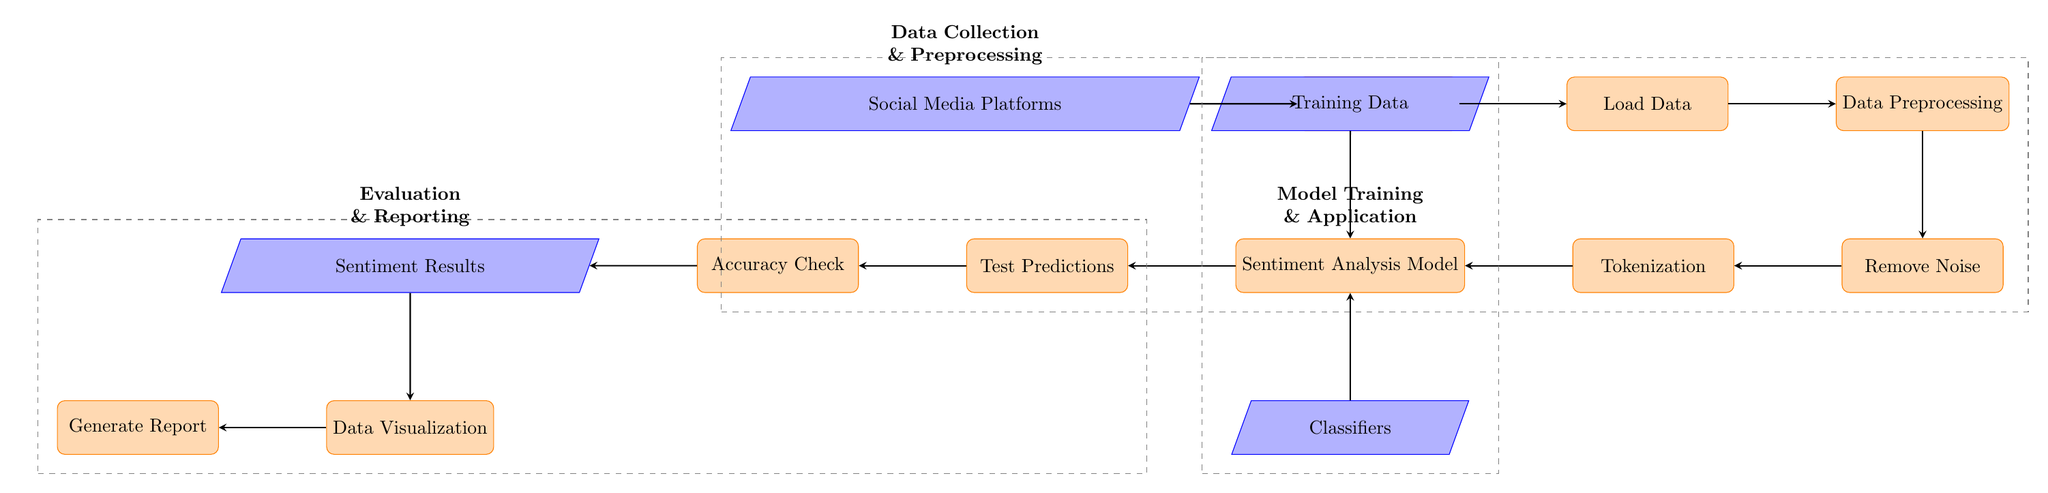What is the first step in the workflow? The first step in the workflow is represented by the node labeled "Social Media Platforms," which signifies where data is sourced from for further processing.
Answer: Social Media Platforms How many nodes are represented in the diagram? By counting each distinct labeled box in the diagram, we find there are a total of 12 nodes representing various parts of the workflow.
Answer: 12 What is the purpose of the "Remove Noise" step? The "Remove Noise" step refers to the process of cleaning the data to eliminate irrelevant or unhelpful information that could hinder the analysis.
Answer: Cleaning data What types of data are used for the "Sentiment Analysis Model"? The model utilizes "Training Data" as an essential input for its learning process, along with various "Classifiers" that help determine sentiment.
Answer: Training Data, Classifiers What flow follows after "Data Visualization"? After "Data Visualization," the next step in the workflow is indicated by the node labeled "Generate Report," which represents the output of the visual analysis.
Answer: Generate Report Which process directly precedes "Accuracy Check"? The node that immediately comes before "Accuracy Check" is labeled "Test Predictions," which indicates that the model's predictions are evaluated for accuracy next in the flow.
Answer: Test Predictions What is represented by the dashed boxes in the diagram? The dashed boxes encapsulate groups of processes with similar functions, indicating that the steps within each box belong to a broader category of the workflow: Data Collection & Preprocessing, Model Training & Application, and Evaluation & Reporting.
Answer: Groups of processes How is "Tokenization" related to "Sentiment Analysis Model"? "Tokenization" is directly linked to the "Sentiment Analysis Model," as it is a preprocessing step that prepares the data by breaking text into smaller components (tokens) that the model can analyze.
Answer: Preprocessing step What is the type of the node "Sentiment Results"? The node labeled "Sentiment Results" is classified as a data type node, representing the output generated from the sentiment analysis process after evaluation.
Answer: Data type node 